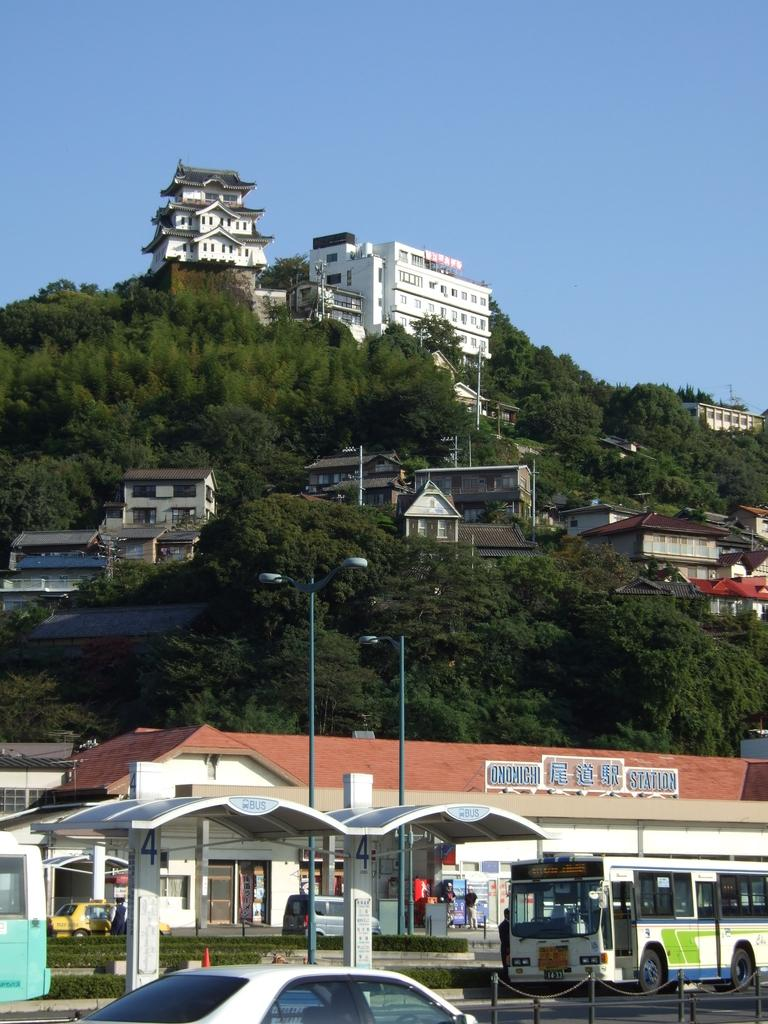What types of objects can be seen in the image? There are vehicles, lights on poles, a shed, and buildings visible in the image. What type of vegetation is present in the image? There is grass in the image. What can be seen in the background of the image? In the background, there are trees and buildings visible. What is the color of the sky in the background? The sky in the background is blue. Can you describe the mother holding the orange in the image? There is no mother or orange present in the image. What is the texture of the flesh visible in the image? There is no flesh visible in the image. 